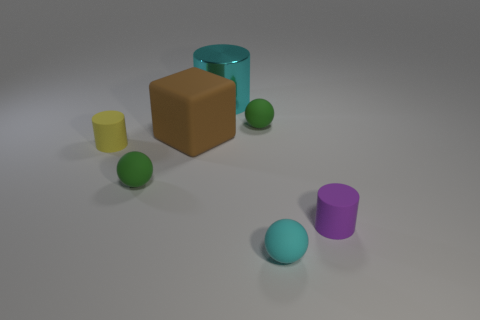Add 1 brown rubber objects. How many objects exist? 8 Subtract all cylinders. How many objects are left? 4 Add 4 cyan matte balls. How many cyan matte balls exist? 5 Subtract 1 brown blocks. How many objects are left? 6 Subtract all tiny red matte objects. Subtract all small green things. How many objects are left? 5 Add 1 small purple cylinders. How many small purple cylinders are left? 2 